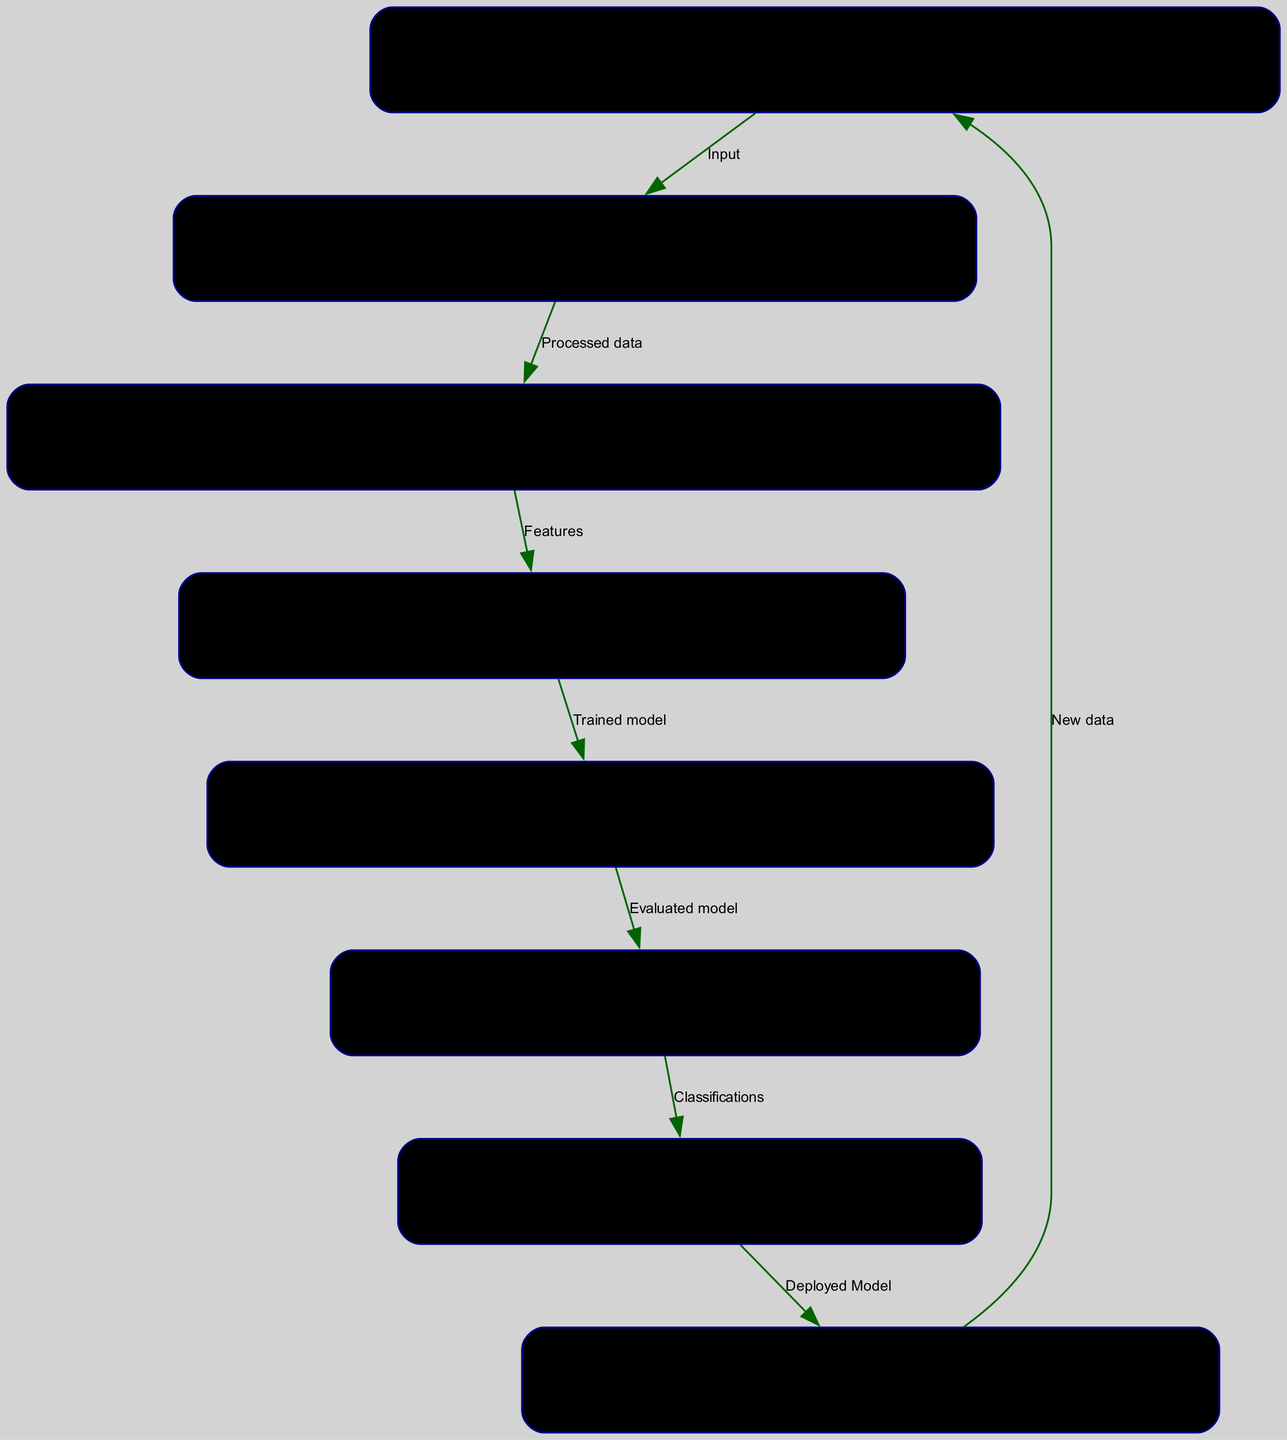What is the first node in the diagram? The first node in the diagram is labeled "Data Collection," which indicates the starting point of the process.
Answer: Data Collection How many nodes are present in the diagram? By counting the nodes listed in the data, there are eight distinct nodes representing different stages of the machine learning process.
Answer: 8 What type of model is used in the "Model Training" node? The "Model Training" node mentions the use of models like ResNet or Inception to train on extracted features from artwork images.
Answer: ResNet or Inception What is the output of the "Model Evaluation" node? The output from the "Model Evaluation" node is the evaluated model, which has been validated using various performance metrics derived from the training process.
Answer: Evaluated model Which node directly follows "Feature Extraction"? Following the "Feature Extraction" node, the next node is "Model Training," indicating that the extracted features are used to train the models.
Answer: Model Training How many edges are there in the diagram? The edges are the connections between the nodes, and by counting them based on the data, there are seven edges representing the flow from one stage to another.
Answer: 7 What feedback mechanism is described in the diagram? The "Feedback Loop" node depicts the mechanism for regular model updates and retraining, indicating a continuous improvement process by incorporating new artwork and feedback.
Answer: Regular model updates Which node is described as classifying artworks into specific styles? The "Style Classification" node is specifically designed for classifying artworks into predefined styles like Abstract, Realism, and Surrealism.
Answer: Style Classification What stage comes after the deployment of the model? After the deployment of the model as described in the "Deployment" node, the feedback loop is initiated for ongoing updates and retraining based on new data.
Answer: Feedback Loop 